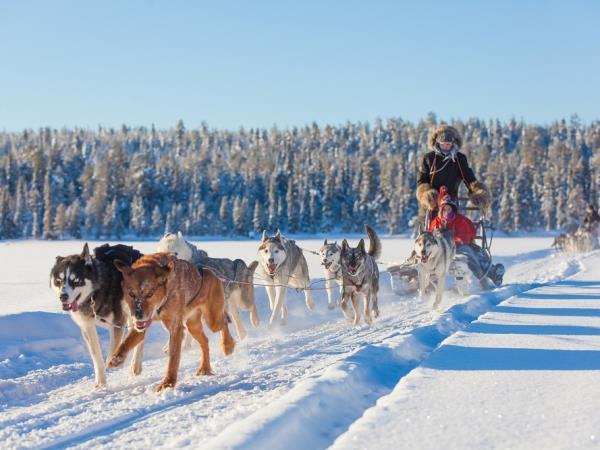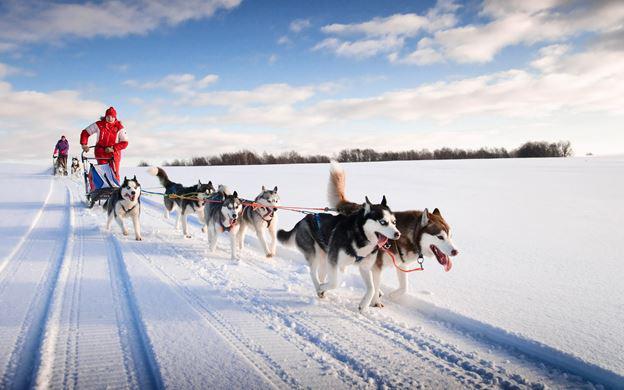The first image is the image on the left, the second image is the image on the right. Considering the images on both sides, is "In one image, dog sleds are traveling close to and between large snow covered trees." valid? Answer yes or no. No. 